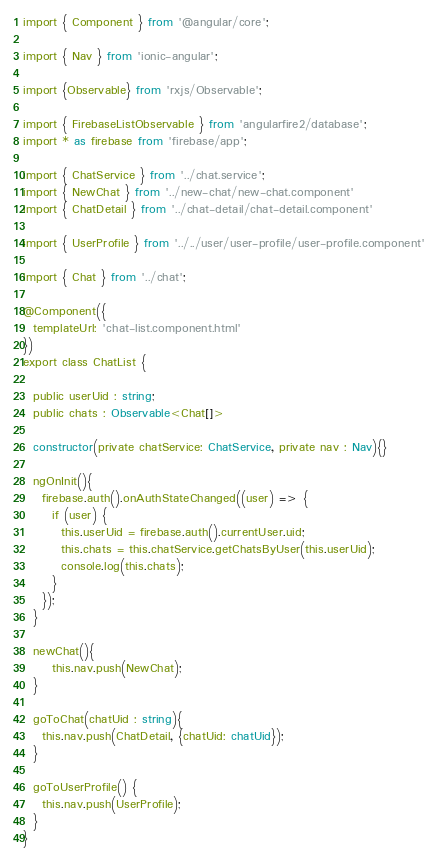<code> <loc_0><loc_0><loc_500><loc_500><_TypeScript_>import { Component } from '@angular/core';

import { Nav } from 'ionic-angular';

import {Observable} from 'rxjs/Observable';

import { FirebaseListObservable } from 'angularfire2/database';
import * as firebase from 'firebase/app';

import { ChatService } from '../chat.service';
import { NewChat } from '../new-chat/new-chat.component'
import { ChatDetail } from '../chat-detail/chat-detail.component'

import { UserProfile } from '../../user/user-profile/user-profile.component'

import { Chat } from '../chat';

@Component({
  templateUrl: 'chat-list.component.html'
})
export class ChatList {

  public userUid : string;
  public chats : Observable<Chat[]>

  constructor(private chatService: ChatService, private nav : Nav){}

  ngOnInit(){
    firebase.auth().onAuthStateChanged((user) => {
      if (user) {
        this.userUid = firebase.auth().currentUser.uid;
        this.chats = this.chatService.getChatsByUser(this.userUid);
        console.log(this.chats);
      }
    });
  }

  newChat(){
      this.nav.push(NewChat);
  }

  goToChat(chatUid : string){
    this.nav.push(ChatDetail, {chatUid: chatUid});
  }

  goToUserProfile() {
    this.nav.push(UserProfile);
  }
}
</code> 